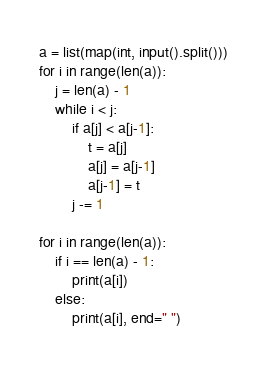<code> <loc_0><loc_0><loc_500><loc_500><_Python_>a = list(map(int, input().split()))
for i in range(len(a)):
    j = len(a) - 1
    while i < j:
        if a[j] < a[j-1]:
            t = a[j]
            a[j] = a[j-1]
            a[j-1] = t
        j -= 1

for i in range(len(a)):
    if i == len(a) - 1:
        print(a[i])
    else:
        print(a[i], end=" ")
        </code> 